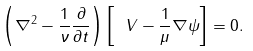<formula> <loc_0><loc_0><loc_500><loc_500>\left ( \nabla ^ { 2 } - \frac { 1 } { \nu } \frac { \partial } { \partial t } \right ) \left [ \ V - \frac { 1 } { \mu } \nabla \psi \right ] = 0 .</formula> 